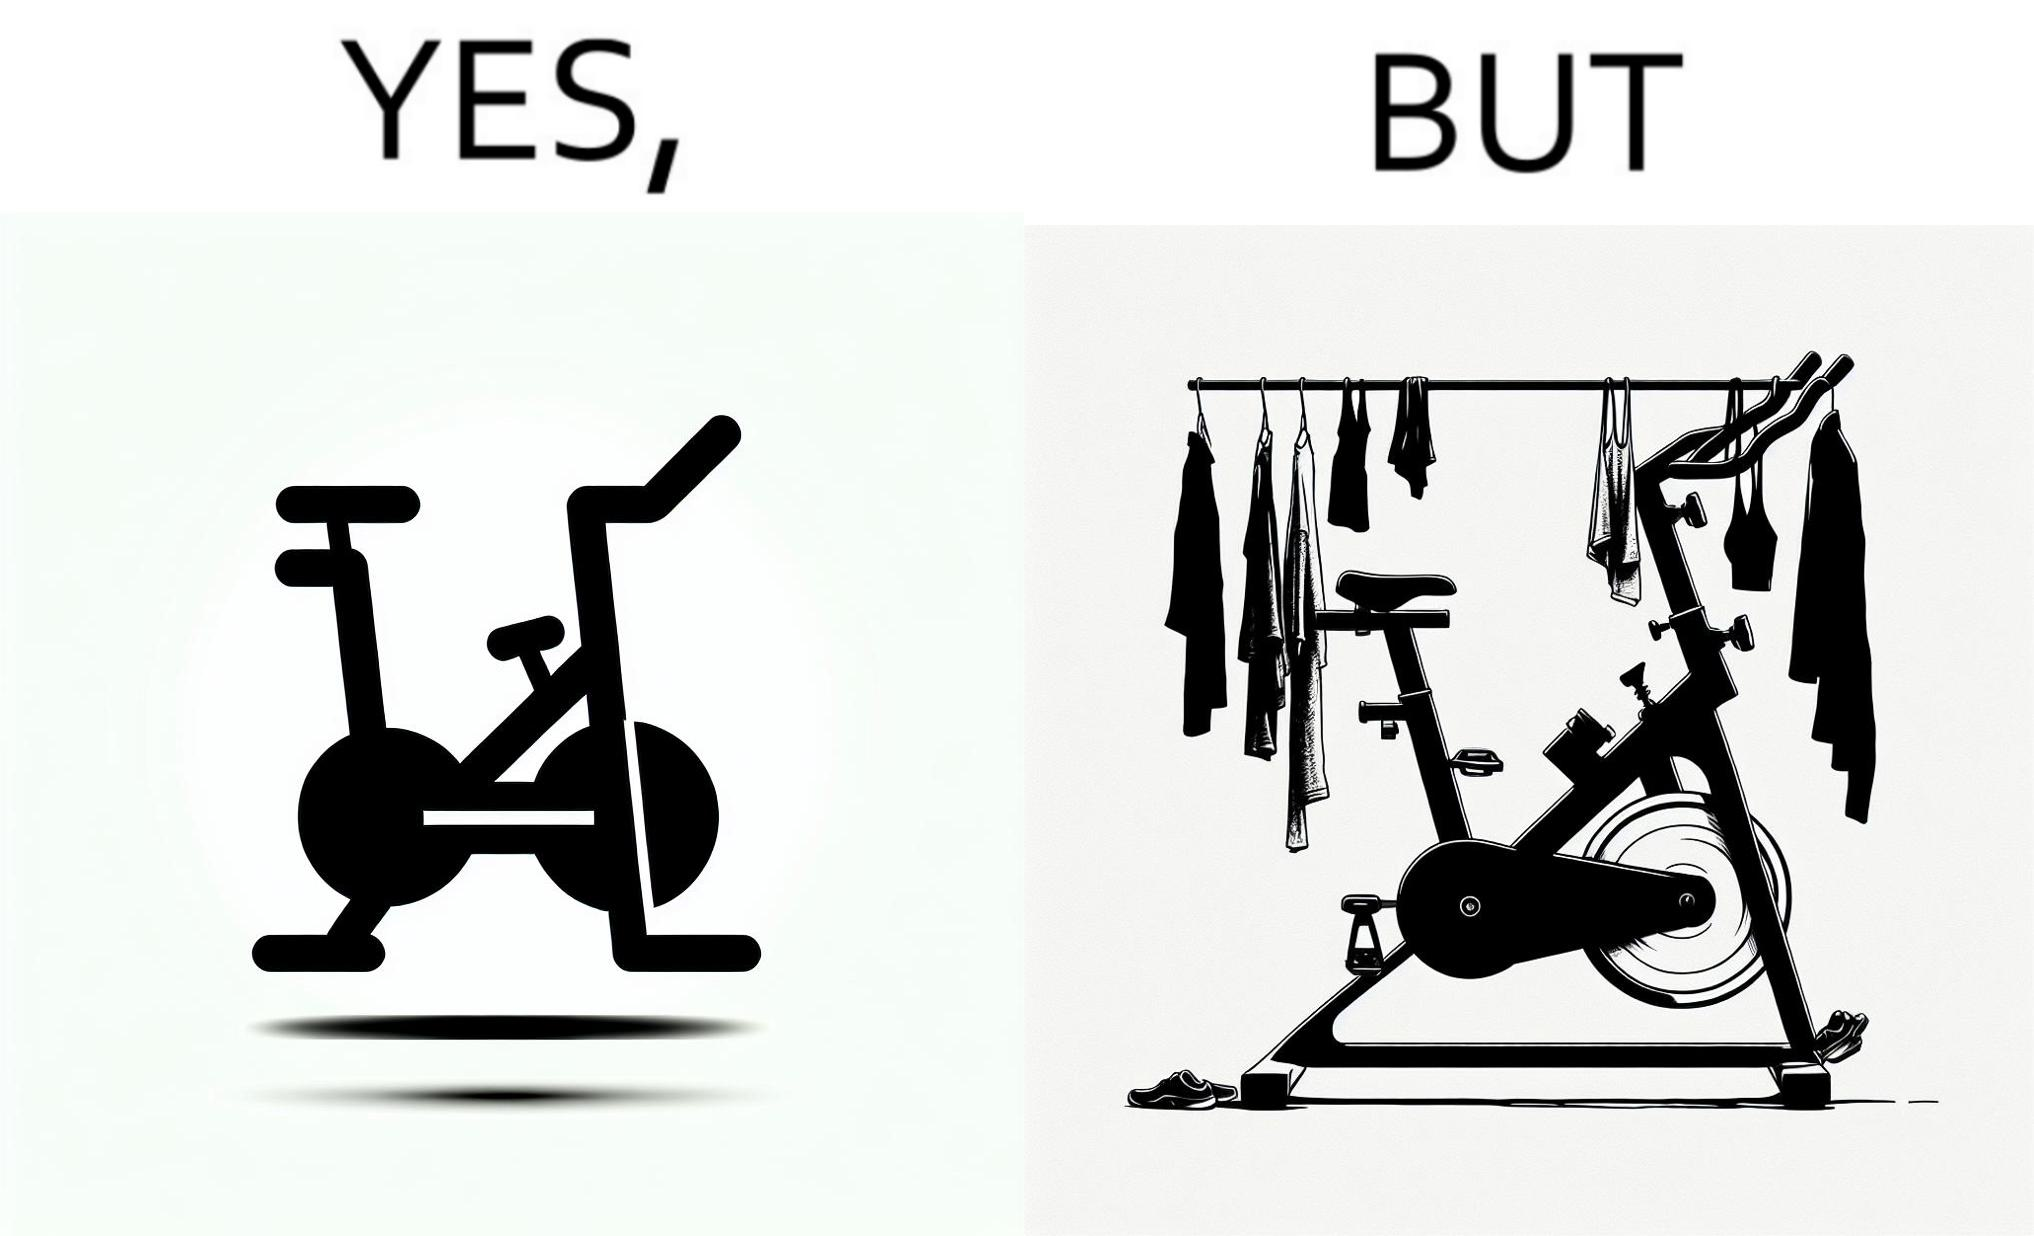What do you see in each half of this image? In the left part of the image: An exercise bike In the right part of the image: An exercise bike being used to hang clothes and other items 